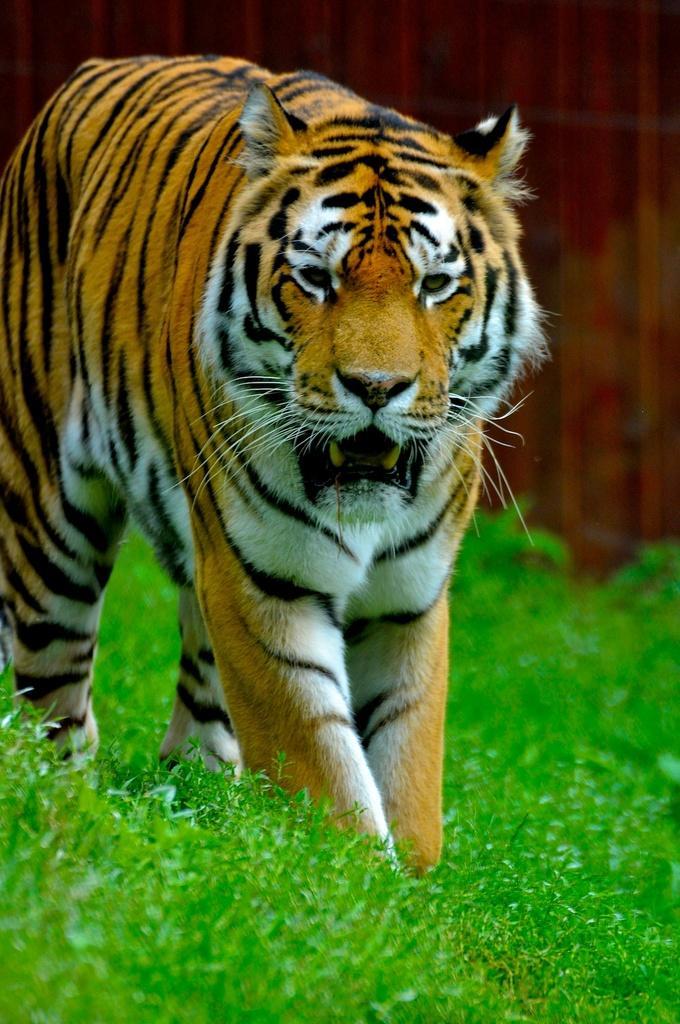Describe this image in one or two sentences. In the center of the image we can see a tiger. At the bottom there is grass. 